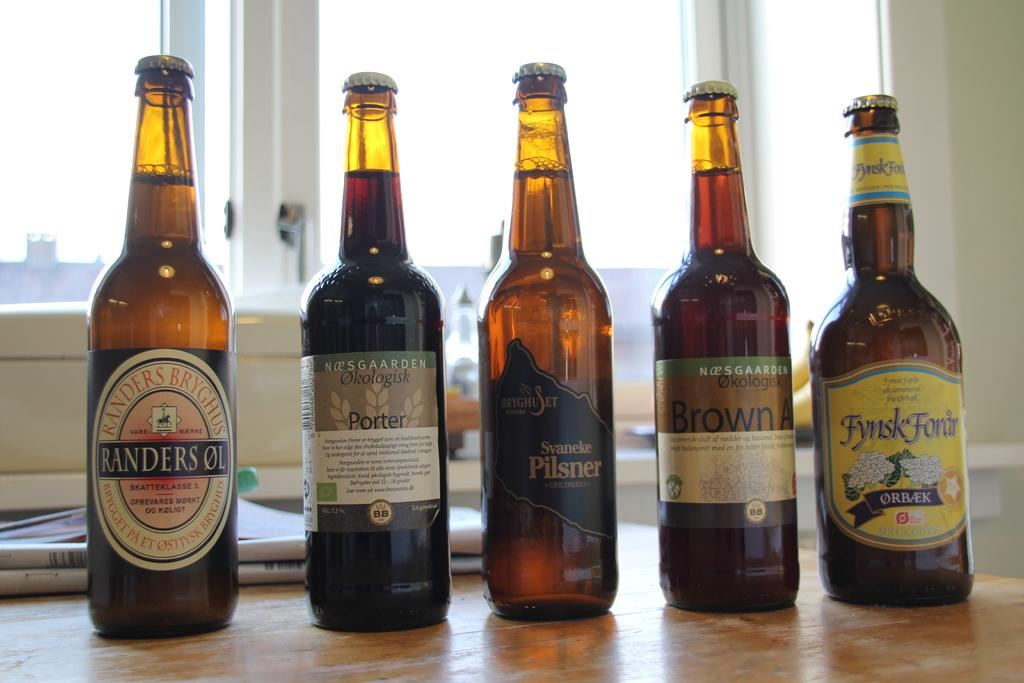<image>
Create a compact narrative representing the image presented. Bottle of Pilsner and Porter sit between other beers on a table. 